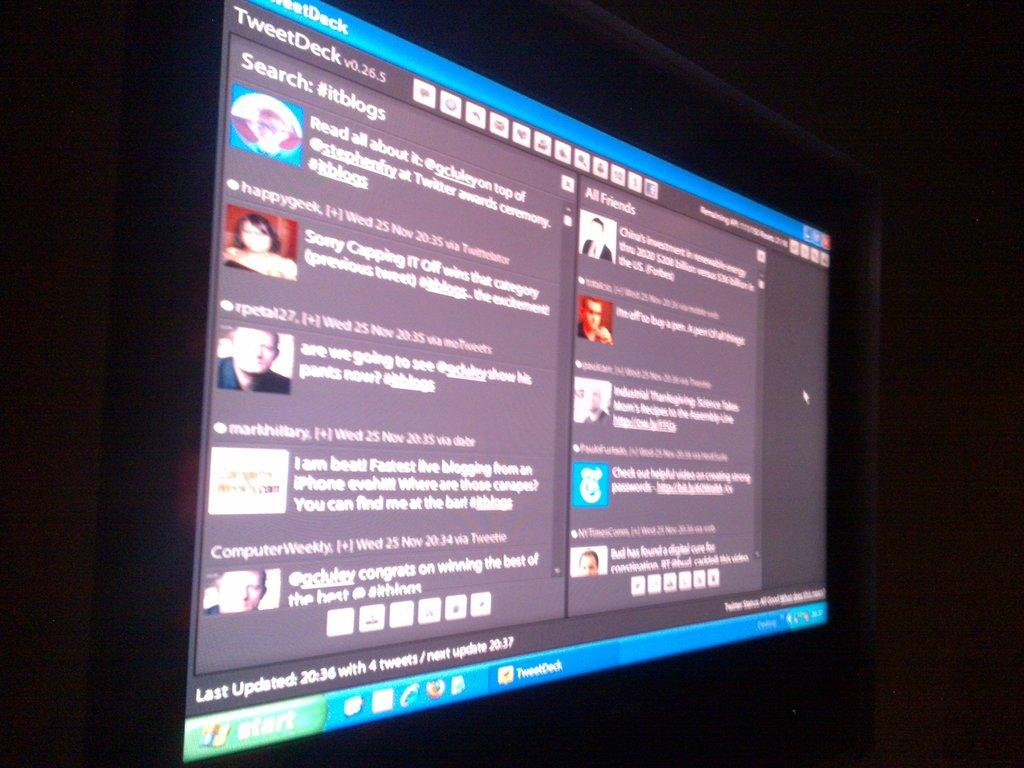Provide a one-sentence caption for the provided image. A computer screen showing descriptions of different tweets. 